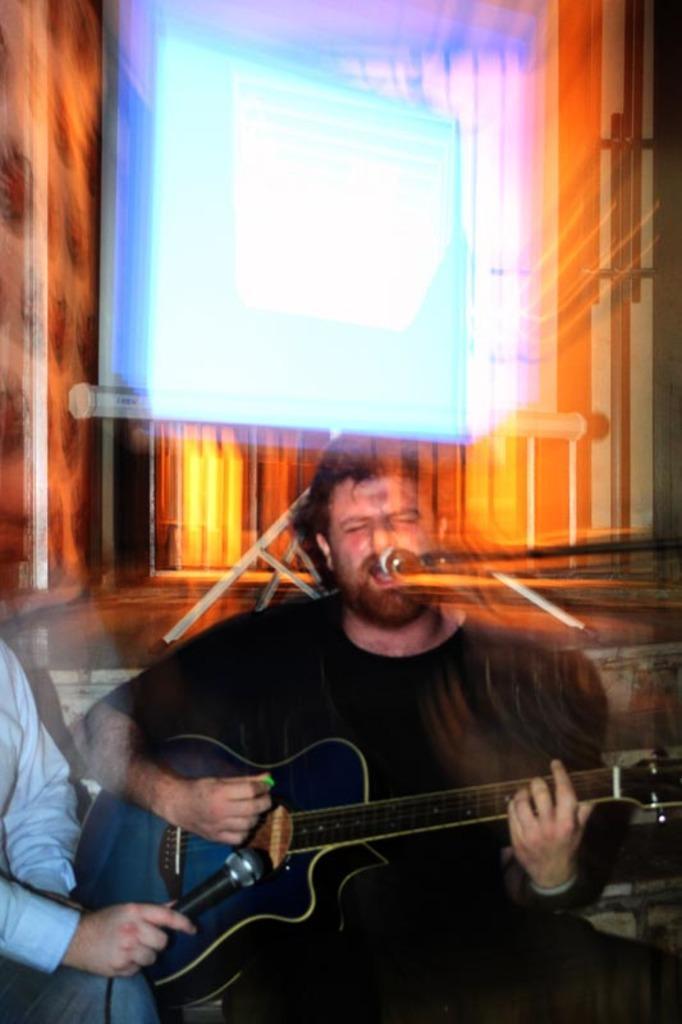Could you give a brief overview of what you see in this image? There is a man sitting holding a guitar in his hands and playing it. There is a microphone in front of him and another guy is holding another microphone in front of the guitar. In the background, there is a projector display screen. 